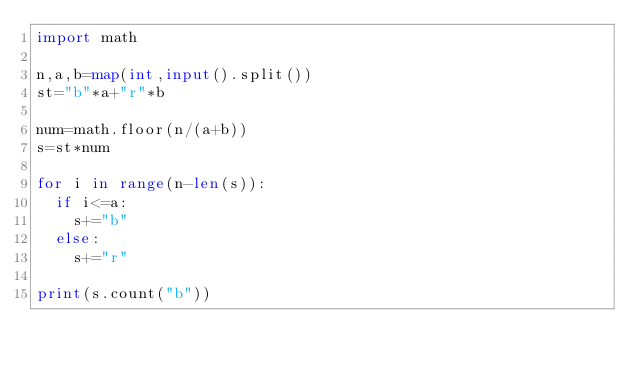Convert code to text. <code><loc_0><loc_0><loc_500><loc_500><_Python_>import math

n,a,b=map(int,input().split())
st="b"*a+"r"*b

num=math.floor(n/(a+b))
s=st*num

for i in range(n-len(s)):
  if i<=a:
    s+="b"
  else:
    s+="r"
    
print(s.count("b"))</code> 